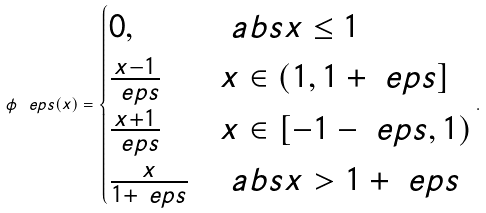<formula> <loc_0><loc_0><loc_500><loc_500>\phi ^ { \ } e p s ( x ) = \begin{cases} 0 , \quad & \ a b s { x } \leq 1 \\ \frac { x - 1 } { \ e p s } & x \in ( 1 , 1 + \ e p s ] \\ \frac { x + 1 } { \ e p s } & x \in [ - 1 - \ e p s , 1 ) \\ \frac { x } { 1 + \ e p s } & \ a b s { x } > 1 + \ e p s \end{cases} .</formula> 